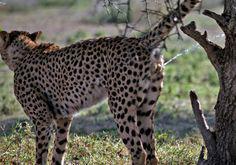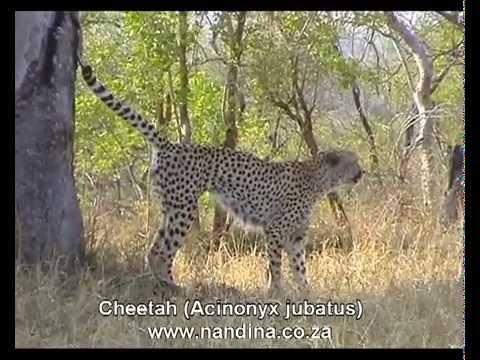The first image is the image on the left, the second image is the image on the right. Given the left and right images, does the statement "The left photo contains three or more cheetahs." hold true? Answer yes or no. No. The first image is the image on the left, the second image is the image on the right. Analyze the images presented: Is the assertion "More than one cat in the image on the left is lying down." valid? Answer yes or no. No. 